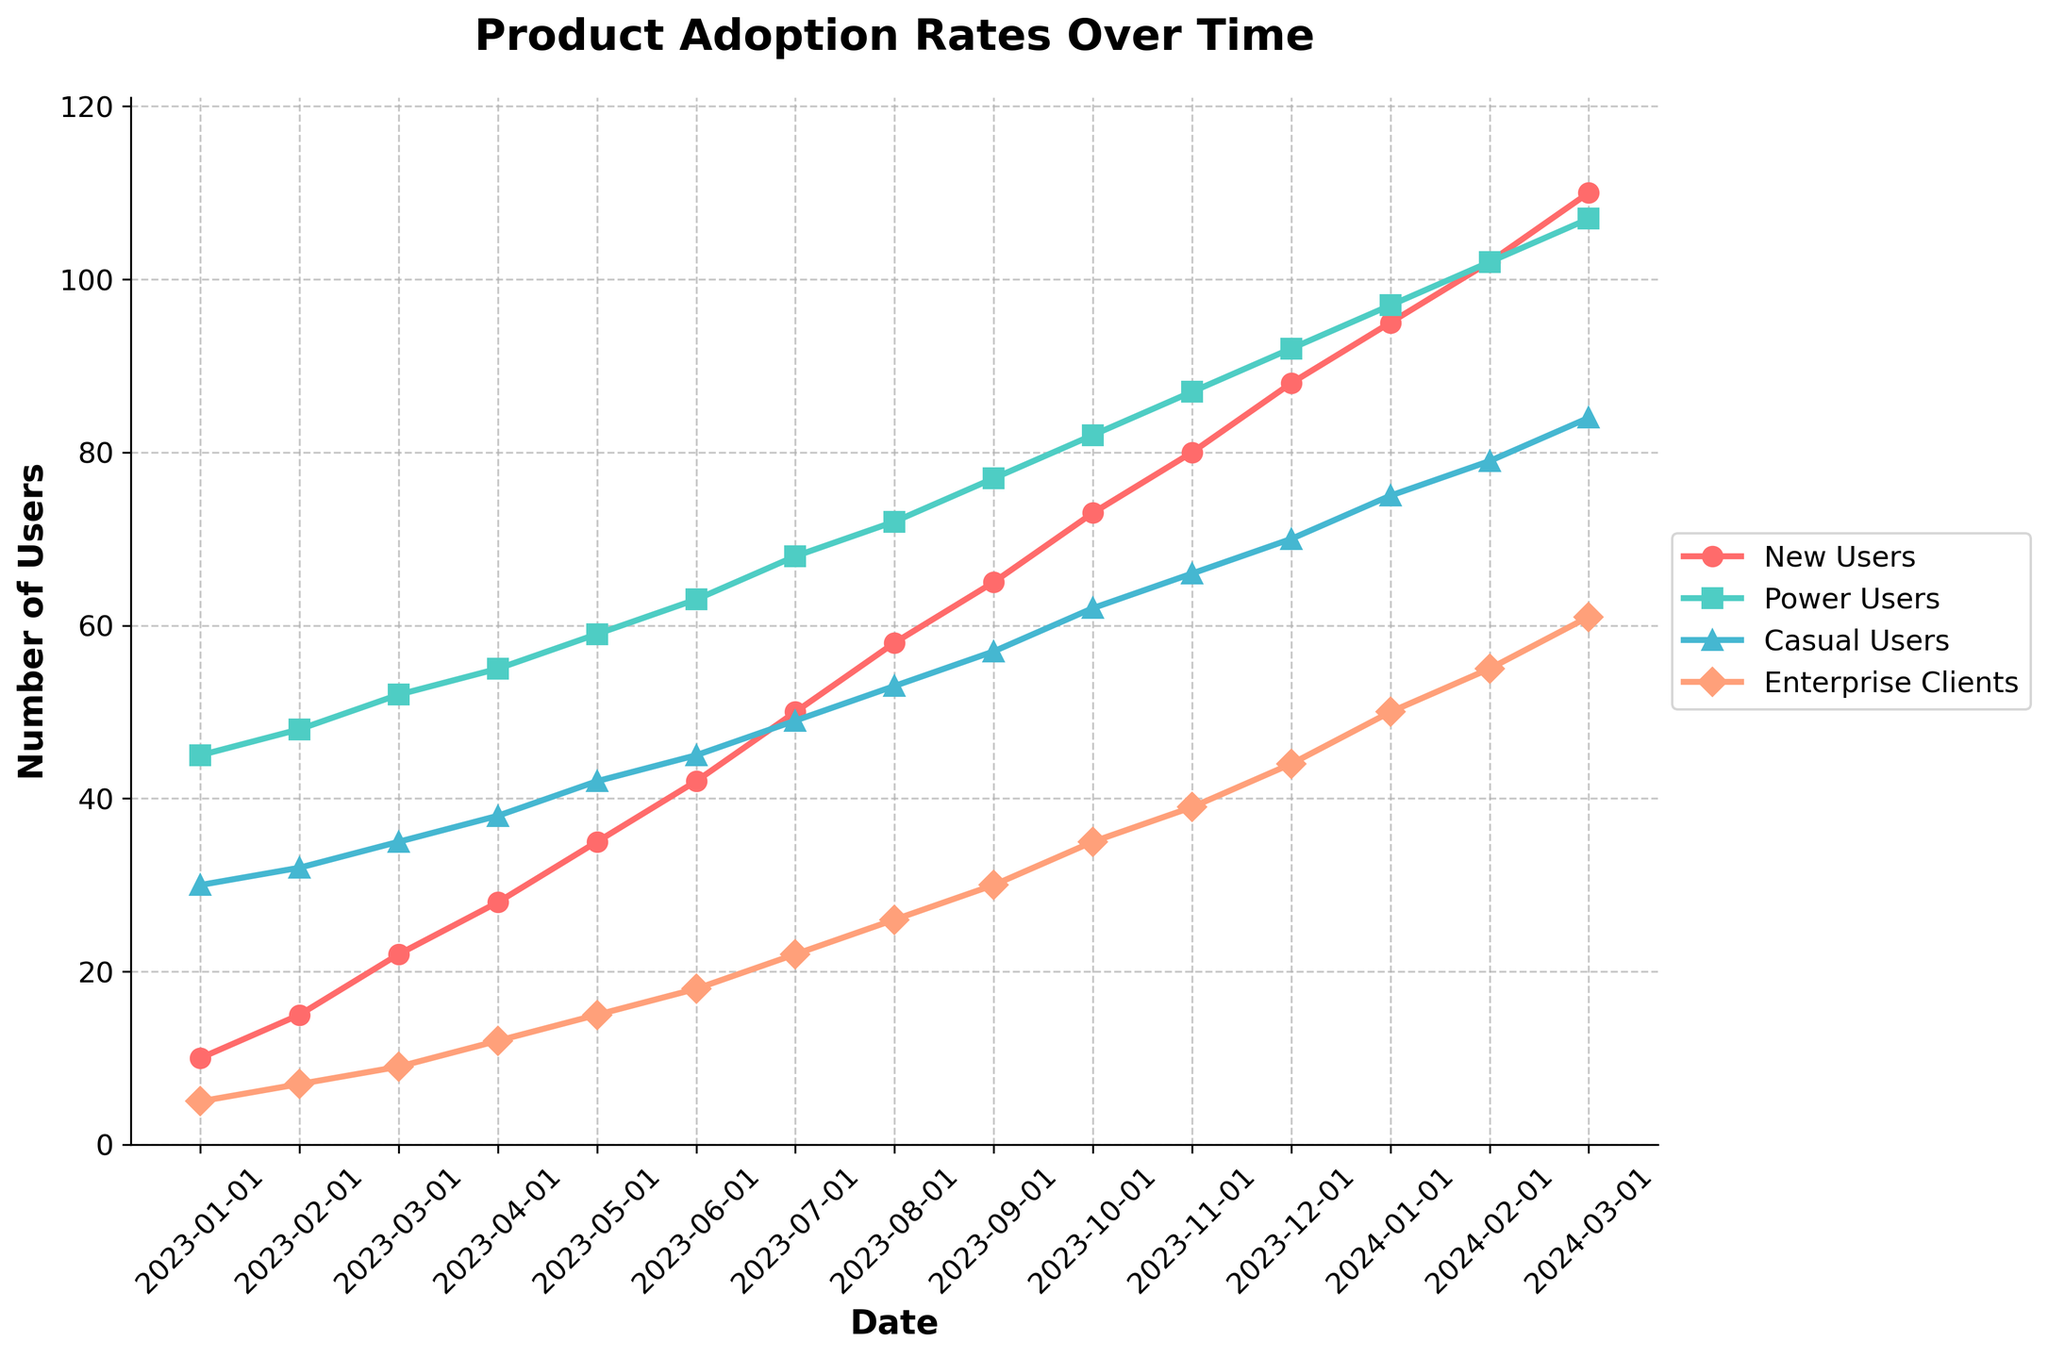What segment has the highest number of users in March 2024? In the chart for March 2024, the "Power Users" segment is at the topmost position compared to other segments.
Answer: Power Users What is the difference between the number of New Users and Enterprise Clients in January 2024? In January 2024, the chart shows that New Users are 95, and Enterprise Clients are 50. Subtracting the two, 95 - 50 = 45.
Answer: 45 Which user segment shows the most significant increase from January 2023 to March 2024? To determine the largest increase, we calculate the difference for each segment from January 2023 to March 2024. New Users: 110 - 10 = 100; Power Users: 107 - 45 = 62; Casual Users: 84 - 30 = 54; Enterprise Clients: 61 - 5 = 56. The New Users segment has the highest increase of 100.
Answer: New Users During what month does the number of Casual Users first exceed the number of Enterprise Clients? By closely analyzing the chart, we see that in May 2023, Casual Users are 42 while Enterprise Clients are 15. Before this, in April, Casual Users are 38 and Enterprise Clients are 12, so May 2023 is the first month Casual Users exceed Enterprise Clients.
Answer: May 2023 Is the growth rate for Power Users consistent over the observed period? To check consistency, we evaluate the linearity of the increase in user numbers for Power Users. The increments per month are mostly around 5 (e.g., 45 to 48, 48 to 52, etc.). Any deviations are minor, indicating a relatively consistent growth.
Answer: Yes What is the combined number of Power Users and Enterprise Clients in December 2023? In December 2023, Power Users number 92, and Enterprise Clients number 44. Adding them, 92 + 44 = 136.
Answer: 136 Compare the total number of users (summed across segments) in January 2023 and January 2024. Which month has more users, and by how much? Calculating the totals: January 2023: 10 + 45 + 30 + 5 = 90; January 2024: 95 + 97 + 75 + 50 = 317. January 2024 has more users. The difference is 317 - 90 = 227.
Answer: January 2024 by 227 What color represents the Casual Users segment in the chart? By referring to the visual legend in the chart, Casual Users are represented by the color blue.
Answer: Blue 